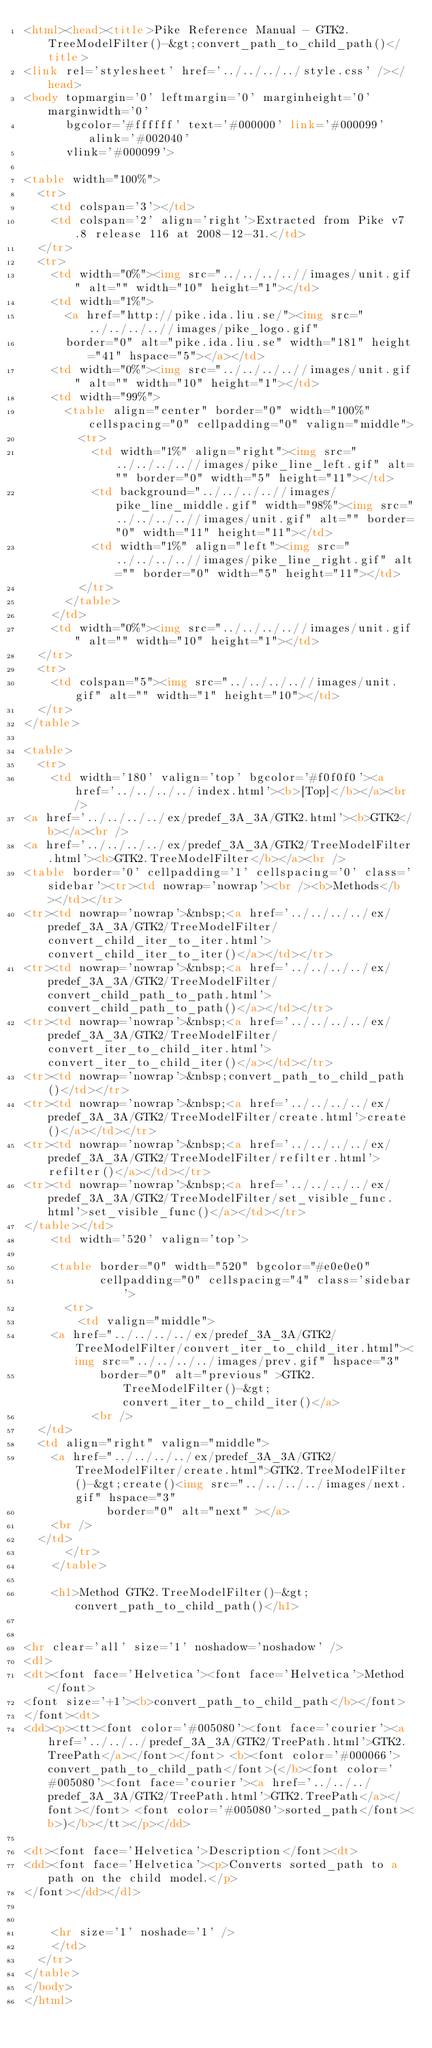<code> <loc_0><loc_0><loc_500><loc_500><_HTML_><html><head><title>Pike Reference Manual - GTK2.TreeModelFilter()-&gt;convert_path_to_child_path()</title>
<link rel='stylesheet' href='../../../../style.css' /></head>
<body topmargin='0' leftmargin='0' marginheight='0' marginwidth='0'
      bgcolor='#ffffff' text='#000000' link='#000099' alink='#002040'
      vlink='#000099'>

<table width="100%">
  <tr>
    <td colspan='3'></td>
    <td colspan='2' align='right'>Extracted from Pike v7.8 release 116 at 2008-12-31.</td>
  </tr>
  <tr>
    <td width="0%"><img src="../../../..//images/unit.gif" alt="" width="10" height="1"></td>
    <td width="1%">
      <a href="http://pike.ida.liu.se/"><img src="../../../..//images/pike_logo.gif"
      border="0" alt="pike.ida.liu.se" width="181" height="41" hspace="5"></a></td>
    <td width="0%"><img src="../../../..//images/unit.gif" alt="" width="10" height="1"></td>
    <td width="99%">
      <table align="center" border="0" width="100%" cellspacing="0" cellpadding="0" valign="middle">
        <tr>
          <td width="1%" align="right"><img src="../../../..//images/pike_line_left.gif" alt="" border="0" width="5" height="11"></td>
          <td background="../../../..//images/pike_line_middle.gif" width="98%"><img src="../../../..//images/unit.gif" alt="" border="0" width="11" height="11"></td>
          <td width="1%" align="left"><img src="../../../..//images/pike_line_right.gif" alt="" border="0" width="5" height="11"></td>
        </tr>
      </table>
    </td>
    <td width="0%"><img src="../../../..//images/unit.gif" alt="" width="10" height="1"></td>
  </tr>
  <tr>
    <td colspan="5"><img src="../../../..//images/unit.gif" alt="" width="1" height="10"></td>
  </tr>
</table>

<table>
  <tr>
    <td width='180' valign='top' bgcolor='#f0f0f0'><a href='../../../../index.html'><b>[Top]</b></a><br />
<a href='../../../../ex/predef_3A_3A/GTK2.html'><b>GTK2</b></a><br />
<a href='../../../../ex/predef_3A_3A/GTK2/TreeModelFilter.html'><b>GTK2.TreeModelFilter</b></a><br />
<table border='0' cellpadding='1' cellspacing='0' class='sidebar'><tr><td nowrap='nowrap'><br /><b>Methods</b></td></tr>
<tr><td nowrap='nowrap'>&nbsp;<a href='../../../../ex/predef_3A_3A/GTK2/TreeModelFilter/convert_child_iter_to_iter.html'>convert_child_iter_to_iter()</a></td></tr>
<tr><td nowrap='nowrap'>&nbsp;<a href='../../../../ex/predef_3A_3A/GTK2/TreeModelFilter/convert_child_path_to_path.html'>convert_child_path_to_path()</a></td></tr>
<tr><td nowrap='nowrap'>&nbsp;<a href='../../../../ex/predef_3A_3A/GTK2/TreeModelFilter/convert_iter_to_child_iter.html'>convert_iter_to_child_iter()</a></td></tr>
<tr><td nowrap='nowrap'>&nbsp;convert_path_to_child_path()</td></tr>
<tr><td nowrap='nowrap'>&nbsp;<a href='../../../../ex/predef_3A_3A/GTK2/TreeModelFilter/create.html'>create()</a></td></tr>
<tr><td nowrap='nowrap'>&nbsp;<a href='../../../../ex/predef_3A_3A/GTK2/TreeModelFilter/refilter.html'>refilter()</a></td></tr>
<tr><td nowrap='nowrap'>&nbsp;<a href='../../../../ex/predef_3A_3A/GTK2/TreeModelFilter/set_visible_func.html'>set_visible_func()</a></td></tr>
</table></td>
    <td width='520' valign='top'>

    <table border="0" width="520" bgcolor="#e0e0e0"
           cellpadding="0" cellspacing="4" class='sidebar'>
      <tr>
        <td valign="middle">
	  <a href="../../../../ex/predef_3A_3A/GTK2/TreeModelFilter/convert_iter_to_child_iter.html"><img src="../../../../images/prev.gif" hspace="3"
	         border="0" alt="previous" >GTK2.TreeModelFilter()-&gt;convert_iter_to_child_iter()</a>
          <br />
	</td>
	<td align="right" valign="middle">
	  <a href="../../../../ex/predef_3A_3A/GTK2/TreeModelFilter/create.html">GTK2.TreeModelFilter()-&gt;create()<img src="../../../../images/next.gif" hspace="3"
	          border="0" alt="next" ></a>
	  <br />
	</td>
      </tr>
    </table>

    <h1>Method GTK2.TreeModelFilter()-&gt;convert_path_to_child_path()</h1>
    

<hr clear='all' size='1' noshadow='noshadow' />
<dl>
<dt><font face='Helvetica'><font face='Helvetica'>Method</font>
<font size='+1'><b>convert_path_to_child_path</b></font>
</font><dt>
<dd><p><tt><font color='#005080'><font face='courier'><a href='../../../predef_3A_3A/GTK2/TreePath.html'>GTK2.TreePath</a></font></font> <b><font color='#000066'>convert_path_to_child_path</font>(</b><font color='#005080'><font face='courier'><a href='../../../predef_3A_3A/GTK2/TreePath.html'>GTK2.TreePath</a></font></font> <font color='#005080'>sorted_path</font><b>)</b></tt></p></dd>

<dt><font face='Helvetica'>Description</font><dt>
<dd><font face='Helvetica'><p>Converts sorted_path to a path on the child model.</p>
</font></dd></dl>


    <hr size='1' noshade='1' />
    </td>
  </tr>
</table>
</body>
</html></code> 